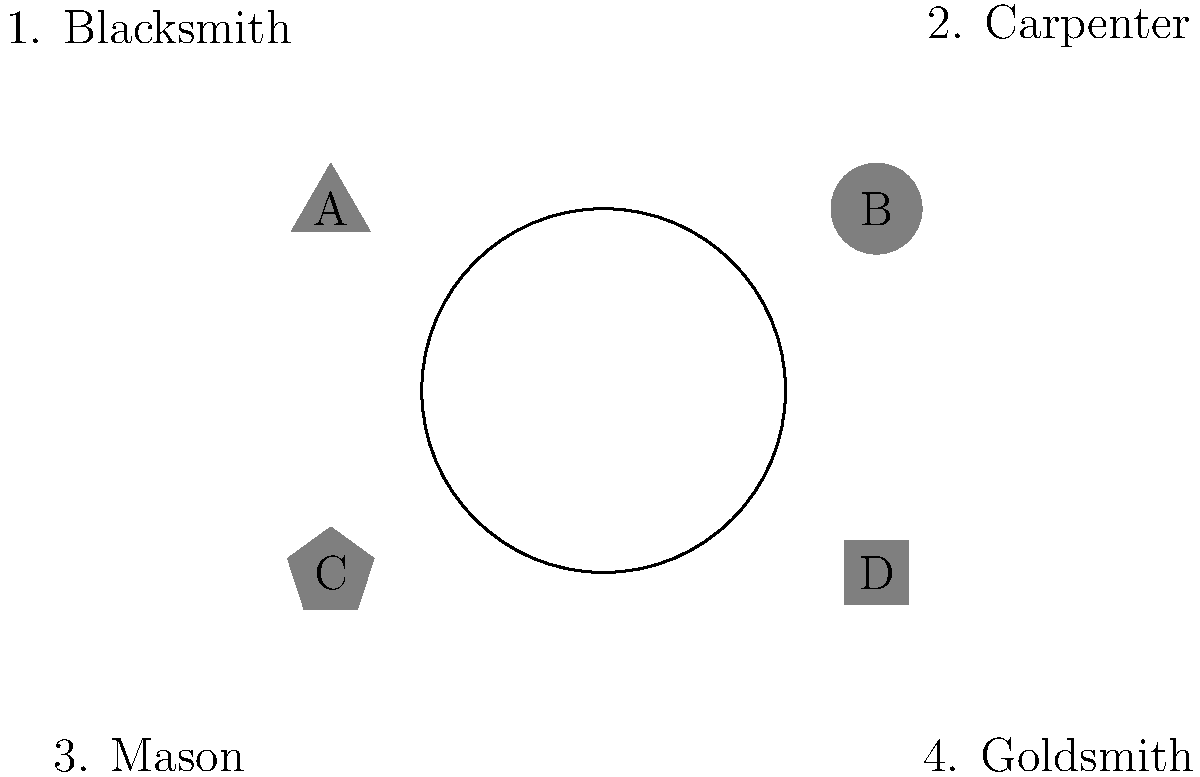Match the craftsman guild emblems (A, B, C, D) to their corresponding trades (1, 2, 3, 4) based on the symbolic representations commonly used in 17th-century European guilds. To match the craftsman guild emblems to their corresponding trades, we need to analyze the symbolic representations used by different guilds in 17th-century Europe:

1. Emblem A (triangle): The triangle shape often represented the blacksmith's trade, symbolizing the anvil or the three elements of fire, water, and metal used in forging.

2. Emblem B (circle): The perfect circle was commonly associated with the carpenter's trade, representing precision and the ability to create rounded objects.

3. Emblem C (pentagon): The pentagon shape was frequently used by masons, symbolizing the five-pointed star or pentagram, which had significance in geometry and architecture.

4. Emblem D (square): The square shape was typically associated with the goldsmith's trade, representing precision, balance, and the four cardinal directions.

Therefore, the correct matching is:
A (triangle) - 1 (Blacksmith)
B (circle) - 2 (Carpenter)
C (pentagon) - 3 (Mason)
D (square) - 4 (Goldsmith)
Answer: A1, B2, C3, D4 